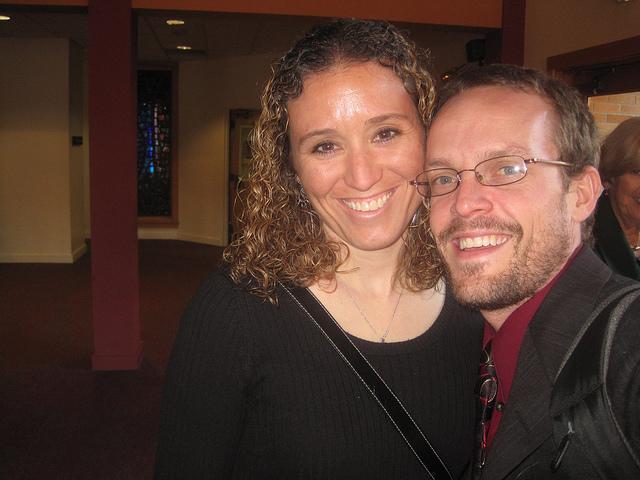How many people are in the picture?
Give a very brief answer. 3. 